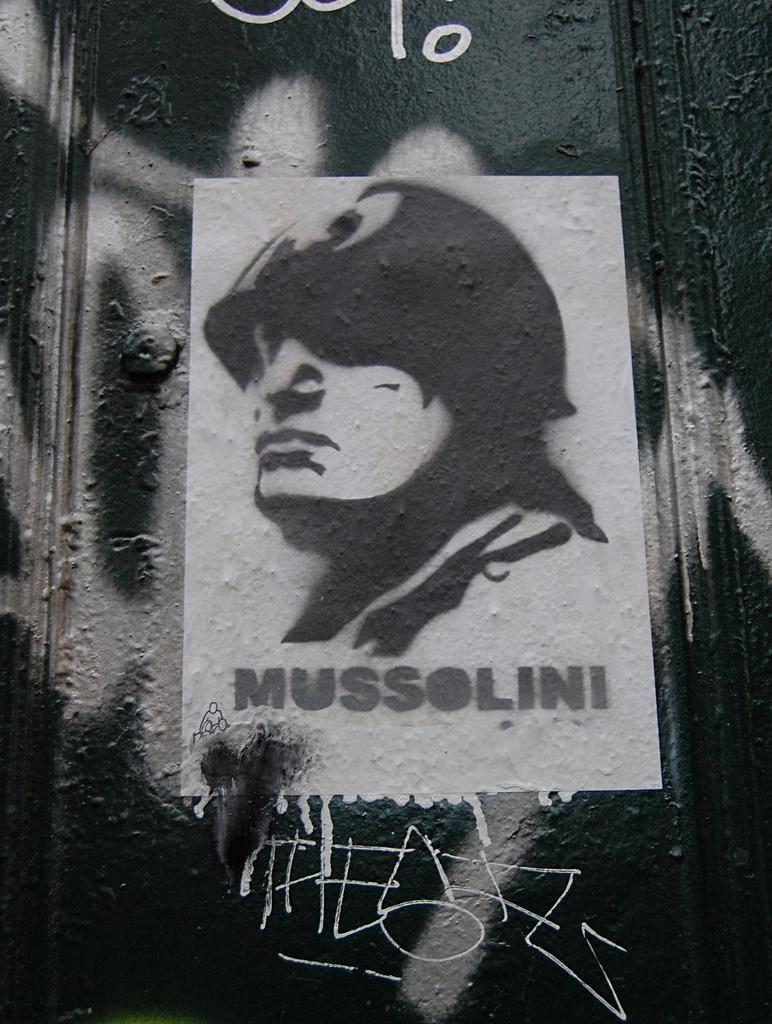What is the color scheme of the image? The image is black and white. What can be seen on the wall in the image? There is a poster of a man on the wall. What is visible in the background of the image? There is a wall in the background. What is written on the wall in the image? There is text written on the wall. What type of stone is used to create the grip on the page in the image? There is no stone or page present in the image; it features a black and white poster of a man on a wall with text written on it. 